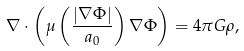<formula> <loc_0><loc_0><loc_500><loc_500>\nabla \cdot \left ( \mu \left ( \frac { \left | \nabla \Phi \right | } { a _ { 0 } } \right ) \nabla \Phi \right ) = 4 \pi G \rho ,</formula> 